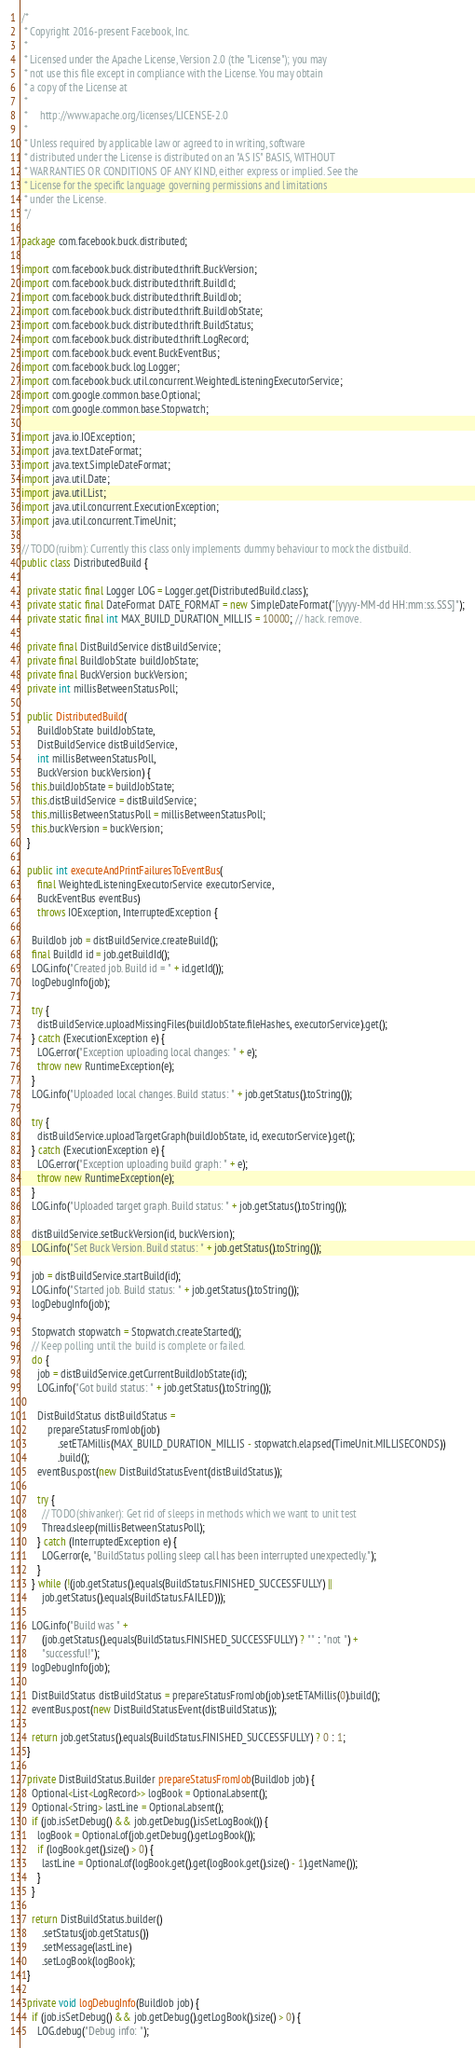Convert code to text. <code><loc_0><loc_0><loc_500><loc_500><_Java_>/*
 * Copyright 2016-present Facebook, Inc.
 *
 * Licensed under the Apache License, Version 2.0 (the "License"); you may
 * not use this file except in compliance with the License. You may obtain
 * a copy of the License at
 *
 *     http://www.apache.org/licenses/LICENSE-2.0
 *
 * Unless required by applicable law or agreed to in writing, software
 * distributed under the License is distributed on an "AS IS" BASIS, WITHOUT
 * WARRANTIES OR CONDITIONS OF ANY KIND, either express or implied. See the
 * License for the specific language governing permissions and limitations
 * under the License.
 */

package com.facebook.buck.distributed;

import com.facebook.buck.distributed.thrift.BuckVersion;
import com.facebook.buck.distributed.thrift.BuildId;
import com.facebook.buck.distributed.thrift.BuildJob;
import com.facebook.buck.distributed.thrift.BuildJobState;
import com.facebook.buck.distributed.thrift.BuildStatus;
import com.facebook.buck.distributed.thrift.LogRecord;
import com.facebook.buck.event.BuckEventBus;
import com.facebook.buck.log.Logger;
import com.facebook.buck.util.concurrent.WeightedListeningExecutorService;
import com.google.common.base.Optional;
import com.google.common.base.Stopwatch;

import java.io.IOException;
import java.text.DateFormat;
import java.text.SimpleDateFormat;
import java.util.Date;
import java.util.List;
import java.util.concurrent.ExecutionException;
import java.util.concurrent.TimeUnit;

// TODO(ruibm): Currently this class only implements dummy behaviour to mock the distbuild.
public class DistributedBuild {

  private static final Logger LOG = Logger.get(DistributedBuild.class);
  private static final DateFormat DATE_FORMAT = new SimpleDateFormat("[yyyy-MM-dd HH:mm:ss.SSS]");
  private static final int MAX_BUILD_DURATION_MILLIS = 10000; // hack. remove.

  private final DistBuildService distBuildService;
  private final BuildJobState buildJobState;
  private final BuckVersion buckVersion;
  private int millisBetweenStatusPoll;

  public DistributedBuild(
      BuildJobState buildJobState,
      DistBuildService distBuildService,
      int millisBetweenStatusPoll,
      BuckVersion buckVersion) {
    this.buildJobState = buildJobState;
    this.distBuildService = distBuildService;
    this.millisBetweenStatusPoll = millisBetweenStatusPoll;
    this.buckVersion = buckVersion;
  }

  public int executeAndPrintFailuresToEventBus(
      final WeightedListeningExecutorService executorService,
      BuckEventBus eventBus)
      throws IOException, InterruptedException {

    BuildJob job = distBuildService.createBuild();
    final BuildId id = job.getBuildId();
    LOG.info("Created job. Build id = " + id.getId());
    logDebugInfo(job);

    try {
      distBuildService.uploadMissingFiles(buildJobState.fileHashes, executorService).get();
    } catch (ExecutionException e) {
      LOG.error("Exception uploading local changes: " + e);
      throw new RuntimeException(e);
    }
    LOG.info("Uploaded local changes. Build status: " + job.getStatus().toString());

    try {
      distBuildService.uploadTargetGraph(buildJobState, id, executorService).get();
    } catch (ExecutionException e) {
      LOG.error("Exception uploading build graph: " + e);
      throw new RuntimeException(e);
    }
    LOG.info("Uploaded target graph. Build status: " + job.getStatus().toString());

    distBuildService.setBuckVersion(id, buckVersion);
    LOG.info("Set Buck Version. Build status: " + job.getStatus().toString());

    job = distBuildService.startBuild(id);
    LOG.info("Started job. Build status: " + job.getStatus().toString());
    logDebugInfo(job);

    Stopwatch stopwatch = Stopwatch.createStarted();
    // Keep polling until the build is complete or failed.
    do {
      job = distBuildService.getCurrentBuildJobState(id);
      LOG.info("Got build status: " + job.getStatus().toString());

      DistBuildStatus distBuildStatus =
          prepareStatusFromJob(job)
              .setETAMillis(MAX_BUILD_DURATION_MILLIS - stopwatch.elapsed(TimeUnit.MILLISECONDS))
              .build();
      eventBus.post(new DistBuildStatusEvent(distBuildStatus));

      try {
        // TODO(shivanker): Get rid of sleeps in methods which we want to unit test
        Thread.sleep(millisBetweenStatusPoll);
      } catch (InterruptedException e) {
        LOG.error(e, "BuildStatus polling sleep call has been interrupted unexpectedly.");
      }
    } while (!(job.getStatus().equals(BuildStatus.FINISHED_SUCCESSFULLY) ||
        job.getStatus().equals(BuildStatus.FAILED)));

    LOG.info("Build was " +
        (job.getStatus().equals(BuildStatus.FINISHED_SUCCESSFULLY) ? "" : "not ") +
        "successful!");
    logDebugInfo(job);

    DistBuildStatus distBuildStatus = prepareStatusFromJob(job).setETAMillis(0).build();
    eventBus.post(new DistBuildStatusEvent(distBuildStatus));

    return job.getStatus().equals(BuildStatus.FINISHED_SUCCESSFULLY) ? 0 : 1;
  }

  private DistBuildStatus.Builder prepareStatusFromJob(BuildJob job) {
    Optional<List<LogRecord>> logBook = Optional.absent();
    Optional<String> lastLine = Optional.absent();
    if (job.isSetDebug() && job.getDebug().isSetLogBook()) {
      logBook = Optional.of(job.getDebug().getLogBook());
      if (logBook.get().size() > 0) {
        lastLine = Optional.of(logBook.get().get(logBook.get().size() - 1).getName());
      }
    }

    return DistBuildStatus.builder()
        .setStatus(job.getStatus())
        .setMessage(lastLine)
        .setLogBook(logBook);
  }

  private void logDebugInfo(BuildJob job) {
    if (job.isSetDebug() && job.getDebug().getLogBook().size() > 0) {
      LOG.debug("Debug info: ");</code> 